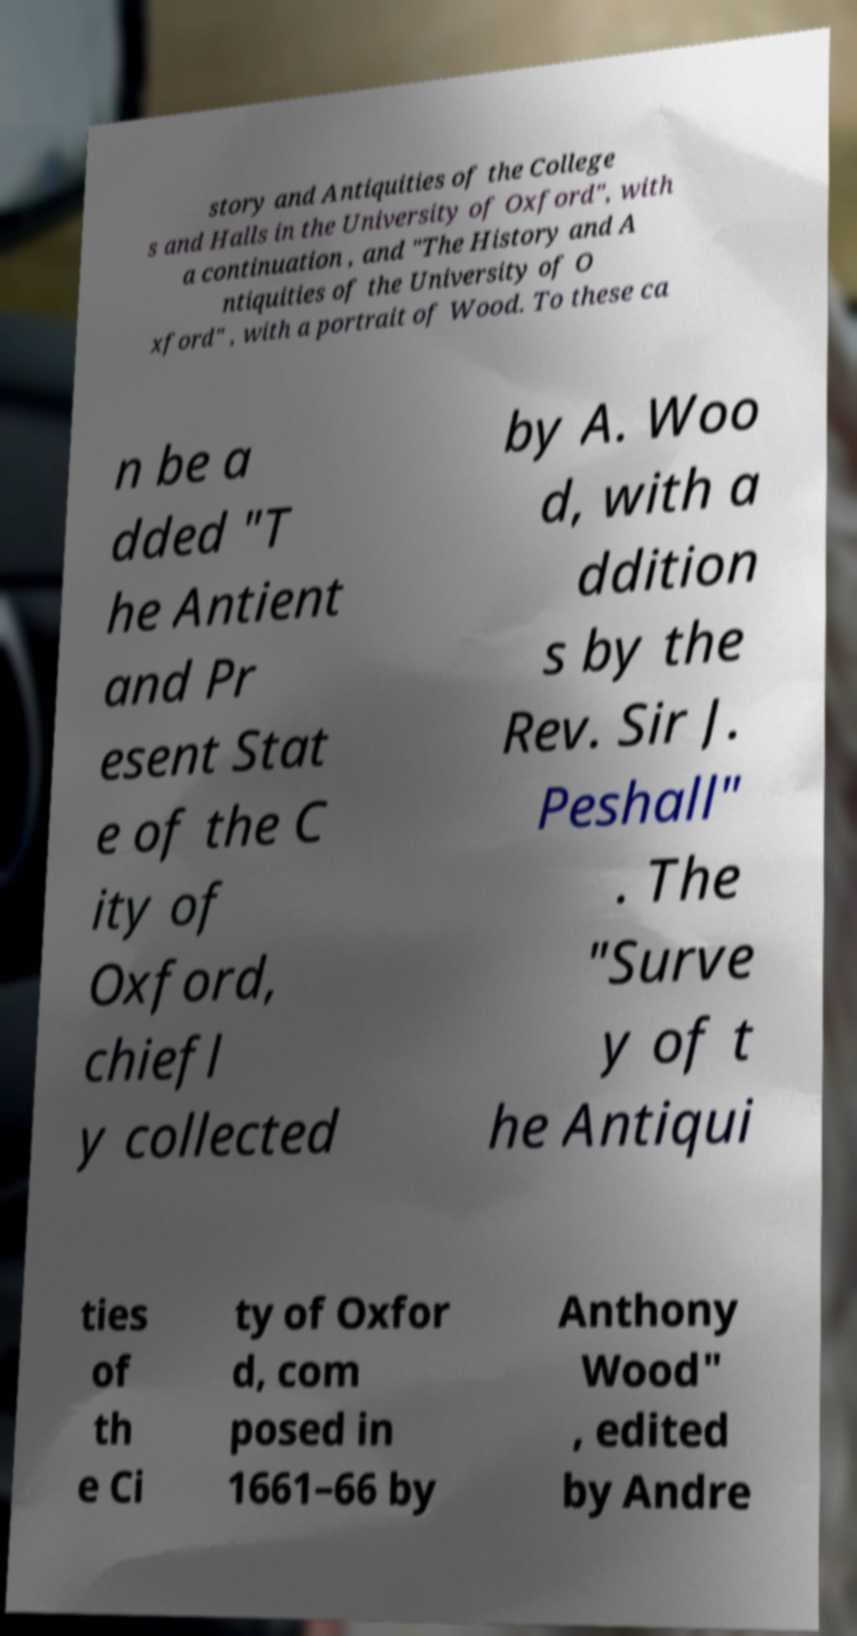Can you accurately transcribe the text from the provided image for me? story and Antiquities of the College s and Halls in the University of Oxford", with a continuation , and "The History and A ntiquities of the University of O xford" , with a portrait of Wood. To these ca n be a dded "T he Antient and Pr esent Stat e of the C ity of Oxford, chiefl y collected by A. Woo d, with a ddition s by the Rev. Sir J. Peshall" . The "Surve y of t he Antiqui ties of th e Ci ty of Oxfor d, com posed in 1661–66 by Anthony Wood" , edited by Andre 